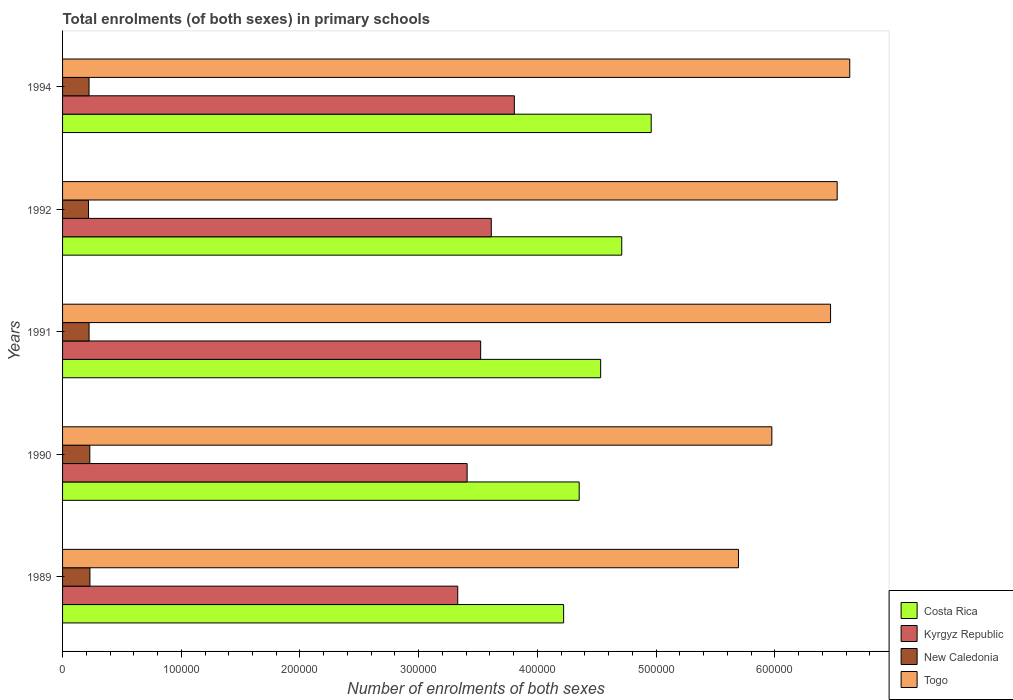Are the number of bars per tick equal to the number of legend labels?
Give a very brief answer. Yes. Are the number of bars on each tick of the Y-axis equal?
Provide a short and direct response. Yes. How many bars are there on the 2nd tick from the top?
Offer a terse response. 4. What is the number of enrolments in primary schools in Togo in 1992?
Ensure brevity in your answer.  6.53e+05. Across all years, what is the maximum number of enrolments in primary schools in Kyrgyz Republic?
Provide a succinct answer. 3.81e+05. Across all years, what is the minimum number of enrolments in primary schools in New Caledonia?
Give a very brief answer. 2.19e+04. In which year was the number of enrolments in primary schools in New Caledonia maximum?
Offer a terse response. 1989. In which year was the number of enrolments in primary schools in Kyrgyz Republic minimum?
Provide a succinct answer. 1989. What is the total number of enrolments in primary schools in Togo in the graph?
Provide a succinct answer. 3.13e+06. What is the difference between the number of enrolments in primary schools in Costa Rica in 1991 and that in 1992?
Your answer should be compact. -1.78e+04. What is the difference between the number of enrolments in primary schools in Togo in 1990 and the number of enrolments in primary schools in Costa Rica in 1994?
Your answer should be very brief. 1.02e+05. What is the average number of enrolments in primary schools in Togo per year?
Your response must be concise. 6.26e+05. In the year 1994, what is the difference between the number of enrolments in primary schools in Costa Rica and number of enrolments in primary schools in Togo?
Provide a succinct answer. -1.67e+05. In how many years, is the number of enrolments in primary schools in Togo greater than 100000 ?
Your answer should be very brief. 5. What is the ratio of the number of enrolments in primary schools in New Caledonia in 1989 to that in 1991?
Ensure brevity in your answer.  1.03. Is the number of enrolments in primary schools in Kyrgyz Republic in 1990 less than that in 1992?
Keep it short and to the point. Yes. Is the difference between the number of enrolments in primary schools in Costa Rica in 1989 and 1994 greater than the difference between the number of enrolments in primary schools in Togo in 1989 and 1994?
Ensure brevity in your answer.  Yes. What is the difference between the highest and the second highest number of enrolments in primary schools in Togo?
Ensure brevity in your answer.  1.06e+04. What is the difference between the highest and the lowest number of enrolments in primary schools in Kyrgyz Republic?
Make the answer very short. 4.77e+04. Is the sum of the number of enrolments in primary schools in New Caledonia in 1989 and 1991 greater than the maximum number of enrolments in primary schools in Kyrgyz Republic across all years?
Offer a terse response. No. Is it the case that in every year, the sum of the number of enrolments in primary schools in Togo and number of enrolments in primary schools in New Caledonia is greater than the sum of number of enrolments in primary schools in Kyrgyz Republic and number of enrolments in primary schools in Costa Rica?
Your answer should be compact. No. What does the 1st bar from the top in 1991 represents?
Make the answer very short. Togo. Is it the case that in every year, the sum of the number of enrolments in primary schools in New Caledonia and number of enrolments in primary schools in Togo is greater than the number of enrolments in primary schools in Kyrgyz Republic?
Ensure brevity in your answer.  Yes. How many bars are there?
Give a very brief answer. 20. Are all the bars in the graph horizontal?
Your response must be concise. Yes. How many years are there in the graph?
Offer a very short reply. 5. What is the difference between two consecutive major ticks on the X-axis?
Make the answer very short. 1.00e+05. Are the values on the major ticks of X-axis written in scientific E-notation?
Make the answer very short. No. Where does the legend appear in the graph?
Keep it short and to the point. Bottom right. What is the title of the graph?
Offer a terse response. Total enrolments (of both sexes) in primary schools. What is the label or title of the X-axis?
Provide a succinct answer. Number of enrolments of both sexes. What is the label or title of the Y-axis?
Give a very brief answer. Years. What is the Number of enrolments of both sexes in Costa Rica in 1989?
Your response must be concise. 4.22e+05. What is the Number of enrolments of both sexes in Kyrgyz Republic in 1989?
Your answer should be compact. 3.33e+05. What is the Number of enrolments of both sexes of New Caledonia in 1989?
Your answer should be compact. 2.31e+04. What is the Number of enrolments of both sexes of Togo in 1989?
Ensure brevity in your answer.  5.69e+05. What is the Number of enrolments of both sexes in Costa Rica in 1990?
Your answer should be very brief. 4.35e+05. What is the Number of enrolments of both sexes in Kyrgyz Republic in 1990?
Ensure brevity in your answer.  3.41e+05. What is the Number of enrolments of both sexes in New Caledonia in 1990?
Provide a short and direct response. 2.30e+04. What is the Number of enrolments of both sexes of Togo in 1990?
Keep it short and to the point. 5.98e+05. What is the Number of enrolments of both sexes in Costa Rica in 1991?
Your answer should be very brief. 4.53e+05. What is the Number of enrolments of both sexes in Kyrgyz Republic in 1991?
Your answer should be very brief. 3.52e+05. What is the Number of enrolments of both sexes in New Caledonia in 1991?
Give a very brief answer. 2.23e+04. What is the Number of enrolments of both sexes of Togo in 1991?
Provide a short and direct response. 6.47e+05. What is the Number of enrolments of both sexes in Costa Rica in 1992?
Offer a terse response. 4.71e+05. What is the Number of enrolments of both sexes in Kyrgyz Republic in 1992?
Your answer should be compact. 3.61e+05. What is the Number of enrolments of both sexes in New Caledonia in 1992?
Make the answer very short. 2.19e+04. What is the Number of enrolments of both sexes of Togo in 1992?
Provide a succinct answer. 6.53e+05. What is the Number of enrolments of both sexes in Costa Rica in 1994?
Your answer should be compact. 4.96e+05. What is the Number of enrolments of both sexes in Kyrgyz Republic in 1994?
Provide a succinct answer. 3.81e+05. What is the Number of enrolments of both sexes of New Caledonia in 1994?
Offer a terse response. 2.23e+04. What is the Number of enrolments of both sexes in Togo in 1994?
Offer a terse response. 6.63e+05. Across all years, what is the maximum Number of enrolments of both sexes in Costa Rica?
Your response must be concise. 4.96e+05. Across all years, what is the maximum Number of enrolments of both sexes of Kyrgyz Republic?
Provide a succinct answer. 3.81e+05. Across all years, what is the maximum Number of enrolments of both sexes in New Caledonia?
Make the answer very short. 2.31e+04. Across all years, what is the maximum Number of enrolments of both sexes of Togo?
Your response must be concise. 6.63e+05. Across all years, what is the minimum Number of enrolments of both sexes of Costa Rica?
Your answer should be compact. 4.22e+05. Across all years, what is the minimum Number of enrolments of both sexes in Kyrgyz Republic?
Your answer should be compact. 3.33e+05. Across all years, what is the minimum Number of enrolments of both sexes of New Caledonia?
Your answer should be very brief. 2.19e+04. Across all years, what is the minimum Number of enrolments of both sexes of Togo?
Your response must be concise. 5.69e+05. What is the total Number of enrolments of both sexes in Costa Rica in the graph?
Your answer should be compact. 2.28e+06. What is the total Number of enrolments of both sexes of Kyrgyz Republic in the graph?
Give a very brief answer. 1.77e+06. What is the total Number of enrolments of both sexes in New Caledonia in the graph?
Your answer should be very brief. 1.13e+05. What is the total Number of enrolments of both sexes of Togo in the graph?
Provide a short and direct response. 3.13e+06. What is the difference between the Number of enrolments of both sexes in Costa Rica in 1989 and that in 1990?
Offer a very short reply. -1.31e+04. What is the difference between the Number of enrolments of both sexes in Kyrgyz Republic in 1989 and that in 1990?
Your response must be concise. -7900. What is the difference between the Number of enrolments of both sexes in New Caledonia in 1989 and that in 1990?
Offer a terse response. 94. What is the difference between the Number of enrolments of both sexes in Togo in 1989 and that in 1990?
Provide a short and direct response. -2.81e+04. What is the difference between the Number of enrolments of both sexes of Costa Rica in 1989 and that in 1991?
Provide a short and direct response. -3.12e+04. What is the difference between the Number of enrolments of both sexes in Kyrgyz Republic in 1989 and that in 1991?
Your answer should be very brief. -1.93e+04. What is the difference between the Number of enrolments of both sexes of New Caledonia in 1989 and that in 1991?
Provide a short and direct response. 727. What is the difference between the Number of enrolments of both sexes of Togo in 1989 and that in 1991?
Offer a terse response. -7.76e+04. What is the difference between the Number of enrolments of both sexes in Costa Rica in 1989 and that in 1992?
Provide a short and direct response. -4.89e+04. What is the difference between the Number of enrolments of both sexes of Kyrgyz Republic in 1989 and that in 1992?
Your answer should be very brief. -2.83e+04. What is the difference between the Number of enrolments of both sexes of New Caledonia in 1989 and that in 1992?
Your response must be concise. 1187. What is the difference between the Number of enrolments of both sexes in Togo in 1989 and that in 1992?
Give a very brief answer. -8.32e+04. What is the difference between the Number of enrolments of both sexes of Costa Rica in 1989 and that in 1994?
Give a very brief answer. -7.38e+04. What is the difference between the Number of enrolments of both sexes in Kyrgyz Republic in 1989 and that in 1994?
Offer a terse response. -4.77e+04. What is the difference between the Number of enrolments of both sexes of New Caledonia in 1989 and that in 1994?
Provide a short and direct response. 744. What is the difference between the Number of enrolments of both sexes in Togo in 1989 and that in 1994?
Your answer should be very brief. -9.37e+04. What is the difference between the Number of enrolments of both sexes in Costa Rica in 1990 and that in 1991?
Your answer should be very brief. -1.81e+04. What is the difference between the Number of enrolments of both sexes of Kyrgyz Republic in 1990 and that in 1991?
Offer a terse response. -1.14e+04. What is the difference between the Number of enrolments of both sexes in New Caledonia in 1990 and that in 1991?
Make the answer very short. 633. What is the difference between the Number of enrolments of both sexes of Togo in 1990 and that in 1991?
Provide a succinct answer. -4.95e+04. What is the difference between the Number of enrolments of both sexes in Costa Rica in 1990 and that in 1992?
Make the answer very short. -3.58e+04. What is the difference between the Number of enrolments of both sexes in Kyrgyz Republic in 1990 and that in 1992?
Offer a terse response. -2.04e+04. What is the difference between the Number of enrolments of both sexes of New Caledonia in 1990 and that in 1992?
Ensure brevity in your answer.  1093. What is the difference between the Number of enrolments of both sexes in Togo in 1990 and that in 1992?
Your response must be concise. -5.50e+04. What is the difference between the Number of enrolments of both sexes in Costa Rica in 1990 and that in 1994?
Provide a short and direct response. -6.07e+04. What is the difference between the Number of enrolments of both sexes of Kyrgyz Republic in 1990 and that in 1994?
Offer a very short reply. -3.98e+04. What is the difference between the Number of enrolments of both sexes in New Caledonia in 1990 and that in 1994?
Your answer should be very brief. 650. What is the difference between the Number of enrolments of both sexes of Togo in 1990 and that in 1994?
Keep it short and to the point. -6.56e+04. What is the difference between the Number of enrolments of both sexes of Costa Rica in 1991 and that in 1992?
Provide a short and direct response. -1.78e+04. What is the difference between the Number of enrolments of both sexes of Kyrgyz Republic in 1991 and that in 1992?
Provide a succinct answer. -8959. What is the difference between the Number of enrolments of both sexes in New Caledonia in 1991 and that in 1992?
Make the answer very short. 460. What is the difference between the Number of enrolments of both sexes of Togo in 1991 and that in 1992?
Keep it short and to the point. -5586. What is the difference between the Number of enrolments of both sexes in Costa Rica in 1991 and that in 1994?
Make the answer very short. -4.26e+04. What is the difference between the Number of enrolments of both sexes in Kyrgyz Republic in 1991 and that in 1994?
Make the answer very short. -2.84e+04. What is the difference between the Number of enrolments of both sexes of Togo in 1991 and that in 1994?
Offer a terse response. -1.62e+04. What is the difference between the Number of enrolments of both sexes of Costa Rica in 1992 and that in 1994?
Your answer should be very brief. -2.48e+04. What is the difference between the Number of enrolments of both sexes of Kyrgyz Republic in 1992 and that in 1994?
Make the answer very short. -1.94e+04. What is the difference between the Number of enrolments of both sexes in New Caledonia in 1992 and that in 1994?
Provide a short and direct response. -443. What is the difference between the Number of enrolments of both sexes of Togo in 1992 and that in 1994?
Your answer should be very brief. -1.06e+04. What is the difference between the Number of enrolments of both sexes of Costa Rica in 1989 and the Number of enrolments of both sexes of Kyrgyz Republic in 1990?
Provide a short and direct response. 8.13e+04. What is the difference between the Number of enrolments of both sexes of Costa Rica in 1989 and the Number of enrolments of both sexes of New Caledonia in 1990?
Provide a short and direct response. 3.99e+05. What is the difference between the Number of enrolments of both sexes in Costa Rica in 1989 and the Number of enrolments of both sexes in Togo in 1990?
Make the answer very short. -1.75e+05. What is the difference between the Number of enrolments of both sexes of Kyrgyz Republic in 1989 and the Number of enrolments of both sexes of New Caledonia in 1990?
Your answer should be compact. 3.10e+05. What is the difference between the Number of enrolments of both sexes of Kyrgyz Republic in 1989 and the Number of enrolments of both sexes of Togo in 1990?
Make the answer very short. -2.65e+05. What is the difference between the Number of enrolments of both sexes of New Caledonia in 1989 and the Number of enrolments of both sexes of Togo in 1990?
Your answer should be very brief. -5.74e+05. What is the difference between the Number of enrolments of both sexes in Costa Rica in 1989 and the Number of enrolments of both sexes in Kyrgyz Republic in 1991?
Give a very brief answer. 6.99e+04. What is the difference between the Number of enrolments of both sexes of Costa Rica in 1989 and the Number of enrolments of both sexes of New Caledonia in 1991?
Offer a terse response. 4.00e+05. What is the difference between the Number of enrolments of both sexes of Costa Rica in 1989 and the Number of enrolments of both sexes of Togo in 1991?
Your answer should be very brief. -2.25e+05. What is the difference between the Number of enrolments of both sexes of Kyrgyz Republic in 1989 and the Number of enrolments of both sexes of New Caledonia in 1991?
Provide a short and direct response. 3.11e+05. What is the difference between the Number of enrolments of both sexes of Kyrgyz Republic in 1989 and the Number of enrolments of both sexes of Togo in 1991?
Keep it short and to the point. -3.14e+05. What is the difference between the Number of enrolments of both sexes of New Caledonia in 1989 and the Number of enrolments of both sexes of Togo in 1991?
Ensure brevity in your answer.  -6.24e+05. What is the difference between the Number of enrolments of both sexes of Costa Rica in 1989 and the Number of enrolments of both sexes of Kyrgyz Republic in 1992?
Make the answer very short. 6.09e+04. What is the difference between the Number of enrolments of both sexes of Costa Rica in 1989 and the Number of enrolments of both sexes of New Caledonia in 1992?
Make the answer very short. 4.00e+05. What is the difference between the Number of enrolments of both sexes in Costa Rica in 1989 and the Number of enrolments of both sexes in Togo in 1992?
Offer a terse response. -2.30e+05. What is the difference between the Number of enrolments of both sexes in Kyrgyz Republic in 1989 and the Number of enrolments of both sexes in New Caledonia in 1992?
Make the answer very short. 3.11e+05. What is the difference between the Number of enrolments of both sexes of Kyrgyz Republic in 1989 and the Number of enrolments of both sexes of Togo in 1992?
Offer a terse response. -3.20e+05. What is the difference between the Number of enrolments of both sexes of New Caledonia in 1989 and the Number of enrolments of both sexes of Togo in 1992?
Ensure brevity in your answer.  -6.29e+05. What is the difference between the Number of enrolments of both sexes in Costa Rica in 1989 and the Number of enrolments of both sexes in Kyrgyz Republic in 1994?
Keep it short and to the point. 4.15e+04. What is the difference between the Number of enrolments of both sexes in Costa Rica in 1989 and the Number of enrolments of both sexes in New Caledonia in 1994?
Offer a terse response. 4.00e+05. What is the difference between the Number of enrolments of both sexes of Costa Rica in 1989 and the Number of enrolments of both sexes of Togo in 1994?
Provide a succinct answer. -2.41e+05. What is the difference between the Number of enrolments of both sexes of Kyrgyz Republic in 1989 and the Number of enrolments of both sexes of New Caledonia in 1994?
Keep it short and to the point. 3.11e+05. What is the difference between the Number of enrolments of both sexes in Kyrgyz Republic in 1989 and the Number of enrolments of both sexes in Togo in 1994?
Your response must be concise. -3.30e+05. What is the difference between the Number of enrolments of both sexes in New Caledonia in 1989 and the Number of enrolments of both sexes in Togo in 1994?
Your answer should be compact. -6.40e+05. What is the difference between the Number of enrolments of both sexes of Costa Rica in 1990 and the Number of enrolments of both sexes of Kyrgyz Republic in 1991?
Ensure brevity in your answer.  8.30e+04. What is the difference between the Number of enrolments of both sexes of Costa Rica in 1990 and the Number of enrolments of both sexes of New Caledonia in 1991?
Provide a succinct answer. 4.13e+05. What is the difference between the Number of enrolments of both sexes of Costa Rica in 1990 and the Number of enrolments of both sexes of Togo in 1991?
Your answer should be very brief. -2.12e+05. What is the difference between the Number of enrolments of both sexes of Kyrgyz Republic in 1990 and the Number of enrolments of both sexes of New Caledonia in 1991?
Offer a very short reply. 3.18e+05. What is the difference between the Number of enrolments of both sexes of Kyrgyz Republic in 1990 and the Number of enrolments of both sexes of Togo in 1991?
Your answer should be very brief. -3.06e+05. What is the difference between the Number of enrolments of both sexes of New Caledonia in 1990 and the Number of enrolments of both sexes of Togo in 1991?
Make the answer very short. -6.24e+05. What is the difference between the Number of enrolments of both sexes in Costa Rica in 1990 and the Number of enrolments of both sexes in Kyrgyz Republic in 1992?
Your answer should be very brief. 7.40e+04. What is the difference between the Number of enrolments of both sexes in Costa Rica in 1990 and the Number of enrolments of both sexes in New Caledonia in 1992?
Keep it short and to the point. 4.13e+05. What is the difference between the Number of enrolments of both sexes of Costa Rica in 1990 and the Number of enrolments of both sexes of Togo in 1992?
Provide a short and direct response. -2.17e+05. What is the difference between the Number of enrolments of both sexes in Kyrgyz Republic in 1990 and the Number of enrolments of both sexes in New Caledonia in 1992?
Ensure brevity in your answer.  3.19e+05. What is the difference between the Number of enrolments of both sexes of Kyrgyz Republic in 1990 and the Number of enrolments of both sexes of Togo in 1992?
Ensure brevity in your answer.  -3.12e+05. What is the difference between the Number of enrolments of both sexes in New Caledonia in 1990 and the Number of enrolments of both sexes in Togo in 1992?
Give a very brief answer. -6.30e+05. What is the difference between the Number of enrolments of both sexes of Costa Rica in 1990 and the Number of enrolments of both sexes of Kyrgyz Republic in 1994?
Make the answer very short. 5.46e+04. What is the difference between the Number of enrolments of both sexes in Costa Rica in 1990 and the Number of enrolments of both sexes in New Caledonia in 1994?
Offer a very short reply. 4.13e+05. What is the difference between the Number of enrolments of both sexes of Costa Rica in 1990 and the Number of enrolments of both sexes of Togo in 1994?
Offer a terse response. -2.28e+05. What is the difference between the Number of enrolments of both sexes in Kyrgyz Republic in 1990 and the Number of enrolments of both sexes in New Caledonia in 1994?
Keep it short and to the point. 3.18e+05. What is the difference between the Number of enrolments of both sexes of Kyrgyz Republic in 1990 and the Number of enrolments of both sexes of Togo in 1994?
Provide a short and direct response. -3.22e+05. What is the difference between the Number of enrolments of both sexes of New Caledonia in 1990 and the Number of enrolments of both sexes of Togo in 1994?
Make the answer very short. -6.40e+05. What is the difference between the Number of enrolments of both sexes of Costa Rica in 1991 and the Number of enrolments of both sexes of Kyrgyz Republic in 1992?
Provide a succinct answer. 9.21e+04. What is the difference between the Number of enrolments of both sexes in Costa Rica in 1991 and the Number of enrolments of both sexes in New Caledonia in 1992?
Offer a terse response. 4.31e+05. What is the difference between the Number of enrolments of both sexes in Costa Rica in 1991 and the Number of enrolments of both sexes in Togo in 1992?
Your answer should be very brief. -1.99e+05. What is the difference between the Number of enrolments of both sexes of Kyrgyz Republic in 1991 and the Number of enrolments of both sexes of New Caledonia in 1992?
Your answer should be very brief. 3.30e+05. What is the difference between the Number of enrolments of both sexes in Kyrgyz Republic in 1991 and the Number of enrolments of both sexes in Togo in 1992?
Provide a short and direct response. -3.00e+05. What is the difference between the Number of enrolments of both sexes of New Caledonia in 1991 and the Number of enrolments of both sexes of Togo in 1992?
Make the answer very short. -6.30e+05. What is the difference between the Number of enrolments of both sexes in Costa Rica in 1991 and the Number of enrolments of both sexes in Kyrgyz Republic in 1994?
Offer a terse response. 7.27e+04. What is the difference between the Number of enrolments of both sexes of Costa Rica in 1991 and the Number of enrolments of both sexes of New Caledonia in 1994?
Make the answer very short. 4.31e+05. What is the difference between the Number of enrolments of both sexes of Costa Rica in 1991 and the Number of enrolments of both sexes of Togo in 1994?
Make the answer very short. -2.10e+05. What is the difference between the Number of enrolments of both sexes in Kyrgyz Republic in 1991 and the Number of enrolments of both sexes in New Caledonia in 1994?
Make the answer very short. 3.30e+05. What is the difference between the Number of enrolments of both sexes of Kyrgyz Republic in 1991 and the Number of enrolments of both sexes of Togo in 1994?
Ensure brevity in your answer.  -3.11e+05. What is the difference between the Number of enrolments of both sexes of New Caledonia in 1991 and the Number of enrolments of both sexes of Togo in 1994?
Ensure brevity in your answer.  -6.41e+05. What is the difference between the Number of enrolments of both sexes in Costa Rica in 1992 and the Number of enrolments of both sexes in Kyrgyz Republic in 1994?
Provide a succinct answer. 9.05e+04. What is the difference between the Number of enrolments of both sexes in Costa Rica in 1992 and the Number of enrolments of both sexes in New Caledonia in 1994?
Provide a succinct answer. 4.49e+05. What is the difference between the Number of enrolments of both sexes in Costa Rica in 1992 and the Number of enrolments of both sexes in Togo in 1994?
Offer a terse response. -1.92e+05. What is the difference between the Number of enrolments of both sexes of Kyrgyz Republic in 1992 and the Number of enrolments of both sexes of New Caledonia in 1994?
Provide a succinct answer. 3.39e+05. What is the difference between the Number of enrolments of both sexes of Kyrgyz Republic in 1992 and the Number of enrolments of both sexes of Togo in 1994?
Make the answer very short. -3.02e+05. What is the difference between the Number of enrolments of both sexes in New Caledonia in 1992 and the Number of enrolments of both sexes in Togo in 1994?
Offer a terse response. -6.41e+05. What is the average Number of enrolments of both sexes in Costa Rica per year?
Provide a succinct answer. 4.56e+05. What is the average Number of enrolments of both sexes of Kyrgyz Republic per year?
Offer a very short reply. 3.54e+05. What is the average Number of enrolments of both sexes of New Caledonia per year?
Provide a succinct answer. 2.25e+04. What is the average Number of enrolments of both sexes in Togo per year?
Keep it short and to the point. 6.26e+05. In the year 1989, what is the difference between the Number of enrolments of both sexes in Costa Rica and Number of enrolments of both sexes in Kyrgyz Republic?
Make the answer very short. 8.92e+04. In the year 1989, what is the difference between the Number of enrolments of both sexes in Costa Rica and Number of enrolments of both sexes in New Caledonia?
Give a very brief answer. 3.99e+05. In the year 1989, what is the difference between the Number of enrolments of both sexes of Costa Rica and Number of enrolments of both sexes of Togo?
Offer a terse response. -1.47e+05. In the year 1989, what is the difference between the Number of enrolments of both sexes of Kyrgyz Republic and Number of enrolments of both sexes of New Caledonia?
Your answer should be compact. 3.10e+05. In the year 1989, what is the difference between the Number of enrolments of both sexes in Kyrgyz Republic and Number of enrolments of both sexes in Togo?
Provide a succinct answer. -2.36e+05. In the year 1989, what is the difference between the Number of enrolments of both sexes of New Caledonia and Number of enrolments of both sexes of Togo?
Make the answer very short. -5.46e+05. In the year 1990, what is the difference between the Number of enrolments of both sexes in Costa Rica and Number of enrolments of both sexes in Kyrgyz Republic?
Keep it short and to the point. 9.44e+04. In the year 1990, what is the difference between the Number of enrolments of both sexes of Costa Rica and Number of enrolments of both sexes of New Caledonia?
Make the answer very short. 4.12e+05. In the year 1990, what is the difference between the Number of enrolments of both sexes of Costa Rica and Number of enrolments of both sexes of Togo?
Provide a short and direct response. -1.62e+05. In the year 1990, what is the difference between the Number of enrolments of both sexes of Kyrgyz Republic and Number of enrolments of both sexes of New Caledonia?
Your answer should be very brief. 3.18e+05. In the year 1990, what is the difference between the Number of enrolments of both sexes of Kyrgyz Republic and Number of enrolments of both sexes of Togo?
Offer a terse response. -2.57e+05. In the year 1990, what is the difference between the Number of enrolments of both sexes of New Caledonia and Number of enrolments of both sexes of Togo?
Make the answer very short. -5.75e+05. In the year 1991, what is the difference between the Number of enrolments of both sexes of Costa Rica and Number of enrolments of both sexes of Kyrgyz Republic?
Your answer should be very brief. 1.01e+05. In the year 1991, what is the difference between the Number of enrolments of both sexes in Costa Rica and Number of enrolments of both sexes in New Caledonia?
Your response must be concise. 4.31e+05. In the year 1991, what is the difference between the Number of enrolments of both sexes in Costa Rica and Number of enrolments of both sexes in Togo?
Provide a short and direct response. -1.94e+05. In the year 1991, what is the difference between the Number of enrolments of both sexes in Kyrgyz Republic and Number of enrolments of both sexes in New Caledonia?
Your answer should be compact. 3.30e+05. In the year 1991, what is the difference between the Number of enrolments of both sexes of Kyrgyz Republic and Number of enrolments of both sexes of Togo?
Your answer should be compact. -2.95e+05. In the year 1991, what is the difference between the Number of enrolments of both sexes in New Caledonia and Number of enrolments of both sexes in Togo?
Your response must be concise. -6.25e+05. In the year 1992, what is the difference between the Number of enrolments of both sexes in Costa Rica and Number of enrolments of both sexes in Kyrgyz Republic?
Your answer should be very brief. 1.10e+05. In the year 1992, what is the difference between the Number of enrolments of both sexes of Costa Rica and Number of enrolments of both sexes of New Caledonia?
Offer a very short reply. 4.49e+05. In the year 1992, what is the difference between the Number of enrolments of both sexes of Costa Rica and Number of enrolments of both sexes of Togo?
Provide a short and direct response. -1.81e+05. In the year 1992, what is the difference between the Number of enrolments of both sexes in Kyrgyz Republic and Number of enrolments of both sexes in New Caledonia?
Your response must be concise. 3.39e+05. In the year 1992, what is the difference between the Number of enrolments of both sexes in Kyrgyz Republic and Number of enrolments of both sexes in Togo?
Offer a terse response. -2.91e+05. In the year 1992, what is the difference between the Number of enrolments of both sexes of New Caledonia and Number of enrolments of both sexes of Togo?
Offer a very short reply. -6.31e+05. In the year 1994, what is the difference between the Number of enrolments of both sexes of Costa Rica and Number of enrolments of both sexes of Kyrgyz Republic?
Provide a succinct answer. 1.15e+05. In the year 1994, what is the difference between the Number of enrolments of both sexes of Costa Rica and Number of enrolments of both sexes of New Caledonia?
Your response must be concise. 4.74e+05. In the year 1994, what is the difference between the Number of enrolments of both sexes of Costa Rica and Number of enrolments of both sexes of Togo?
Your answer should be compact. -1.67e+05. In the year 1994, what is the difference between the Number of enrolments of both sexes in Kyrgyz Republic and Number of enrolments of both sexes in New Caledonia?
Your answer should be very brief. 3.58e+05. In the year 1994, what is the difference between the Number of enrolments of both sexes of Kyrgyz Republic and Number of enrolments of both sexes of Togo?
Offer a terse response. -2.83e+05. In the year 1994, what is the difference between the Number of enrolments of both sexes in New Caledonia and Number of enrolments of both sexes in Togo?
Keep it short and to the point. -6.41e+05. What is the ratio of the Number of enrolments of both sexes of Costa Rica in 1989 to that in 1990?
Give a very brief answer. 0.97. What is the ratio of the Number of enrolments of both sexes in Kyrgyz Republic in 1989 to that in 1990?
Provide a short and direct response. 0.98. What is the ratio of the Number of enrolments of both sexes of New Caledonia in 1989 to that in 1990?
Your response must be concise. 1. What is the ratio of the Number of enrolments of both sexes in Togo in 1989 to that in 1990?
Keep it short and to the point. 0.95. What is the ratio of the Number of enrolments of both sexes of Costa Rica in 1989 to that in 1991?
Give a very brief answer. 0.93. What is the ratio of the Number of enrolments of both sexes in Kyrgyz Republic in 1989 to that in 1991?
Ensure brevity in your answer.  0.95. What is the ratio of the Number of enrolments of both sexes of New Caledonia in 1989 to that in 1991?
Provide a succinct answer. 1.03. What is the ratio of the Number of enrolments of both sexes in Togo in 1989 to that in 1991?
Give a very brief answer. 0.88. What is the ratio of the Number of enrolments of both sexes in Costa Rica in 1989 to that in 1992?
Make the answer very short. 0.9. What is the ratio of the Number of enrolments of both sexes of Kyrgyz Republic in 1989 to that in 1992?
Offer a very short reply. 0.92. What is the ratio of the Number of enrolments of both sexes of New Caledonia in 1989 to that in 1992?
Give a very brief answer. 1.05. What is the ratio of the Number of enrolments of both sexes of Togo in 1989 to that in 1992?
Provide a short and direct response. 0.87. What is the ratio of the Number of enrolments of both sexes in Costa Rica in 1989 to that in 1994?
Give a very brief answer. 0.85. What is the ratio of the Number of enrolments of both sexes in Kyrgyz Republic in 1989 to that in 1994?
Make the answer very short. 0.87. What is the ratio of the Number of enrolments of both sexes in New Caledonia in 1989 to that in 1994?
Your answer should be very brief. 1.03. What is the ratio of the Number of enrolments of both sexes of Togo in 1989 to that in 1994?
Your response must be concise. 0.86. What is the ratio of the Number of enrolments of both sexes in Costa Rica in 1990 to that in 1991?
Offer a terse response. 0.96. What is the ratio of the Number of enrolments of both sexes of Kyrgyz Republic in 1990 to that in 1991?
Offer a very short reply. 0.97. What is the ratio of the Number of enrolments of both sexes of New Caledonia in 1990 to that in 1991?
Offer a terse response. 1.03. What is the ratio of the Number of enrolments of both sexes of Togo in 1990 to that in 1991?
Offer a terse response. 0.92. What is the ratio of the Number of enrolments of both sexes of Costa Rica in 1990 to that in 1992?
Offer a terse response. 0.92. What is the ratio of the Number of enrolments of both sexes in Kyrgyz Republic in 1990 to that in 1992?
Offer a very short reply. 0.94. What is the ratio of the Number of enrolments of both sexes in New Caledonia in 1990 to that in 1992?
Offer a terse response. 1.05. What is the ratio of the Number of enrolments of both sexes of Togo in 1990 to that in 1992?
Your answer should be very brief. 0.92. What is the ratio of the Number of enrolments of both sexes of Costa Rica in 1990 to that in 1994?
Provide a short and direct response. 0.88. What is the ratio of the Number of enrolments of both sexes of Kyrgyz Republic in 1990 to that in 1994?
Your answer should be very brief. 0.9. What is the ratio of the Number of enrolments of both sexes in New Caledonia in 1990 to that in 1994?
Provide a succinct answer. 1.03. What is the ratio of the Number of enrolments of both sexes of Togo in 1990 to that in 1994?
Provide a short and direct response. 0.9. What is the ratio of the Number of enrolments of both sexes in Costa Rica in 1991 to that in 1992?
Provide a succinct answer. 0.96. What is the ratio of the Number of enrolments of both sexes in Kyrgyz Republic in 1991 to that in 1992?
Make the answer very short. 0.98. What is the ratio of the Number of enrolments of both sexes of Costa Rica in 1991 to that in 1994?
Provide a succinct answer. 0.91. What is the ratio of the Number of enrolments of both sexes in Kyrgyz Republic in 1991 to that in 1994?
Provide a short and direct response. 0.93. What is the ratio of the Number of enrolments of both sexes in Togo in 1991 to that in 1994?
Your answer should be compact. 0.98. What is the ratio of the Number of enrolments of both sexes of Costa Rica in 1992 to that in 1994?
Provide a short and direct response. 0.95. What is the ratio of the Number of enrolments of both sexes in Kyrgyz Republic in 1992 to that in 1994?
Offer a very short reply. 0.95. What is the ratio of the Number of enrolments of both sexes in New Caledonia in 1992 to that in 1994?
Make the answer very short. 0.98. What is the difference between the highest and the second highest Number of enrolments of both sexes in Costa Rica?
Your answer should be compact. 2.48e+04. What is the difference between the highest and the second highest Number of enrolments of both sexes in Kyrgyz Republic?
Make the answer very short. 1.94e+04. What is the difference between the highest and the second highest Number of enrolments of both sexes of New Caledonia?
Provide a succinct answer. 94. What is the difference between the highest and the second highest Number of enrolments of both sexes in Togo?
Keep it short and to the point. 1.06e+04. What is the difference between the highest and the lowest Number of enrolments of both sexes of Costa Rica?
Offer a very short reply. 7.38e+04. What is the difference between the highest and the lowest Number of enrolments of both sexes of Kyrgyz Republic?
Your answer should be very brief. 4.77e+04. What is the difference between the highest and the lowest Number of enrolments of both sexes of New Caledonia?
Make the answer very short. 1187. What is the difference between the highest and the lowest Number of enrolments of both sexes of Togo?
Your answer should be compact. 9.37e+04. 